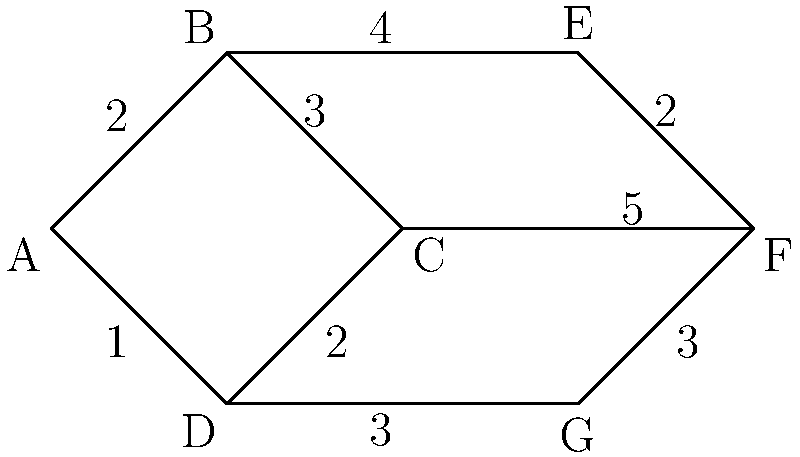As an airline executive, you're tasked with optimizing the security checkpoint layout at a major airport. The graph represents different security stations (nodes) and the paths between them (edges). The weights on the edges represent the average time (in minutes) it takes passengers to move between stations. What is the minimum total time required for a passenger to pass through all security stations, visiting each station exactly once and returning to the starting point? To solve this problem, we need to find the Hamiltonian cycle with the minimum total weight in the given graph. This is known as the Traveling Salesman Problem (TSP). Here's how we can approach it:

1. Identify all possible Hamiltonian cycles in the graph:
   - A-B-C-D-A
   - A-B-E-F-C-D-A
   - A-B-E-F-G-D-A
   - A-D-G-F-E-B-A
   - A-D-G-F-C-B-A

2. Calculate the total weight for each cycle:
   - A-B-C-D-A: 2 + 3 + 2 + 1 = 8 minutes
   - A-B-E-F-C-D-A: 2 + 4 + 2 + 5 + 2 + 1 = 16 minutes
   - A-B-E-F-G-D-A: 2 + 4 + 2 + 3 + 3 + 1 = 15 minutes
   - A-D-G-F-E-B-A: 1 + 3 + 3 + 2 + 4 + 2 = 15 minutes
   - A-D-G-F-C-B-A: 1 + 3 + 3 + 5 + 3 + 2 = 17 minutes

3. Identify the cycle with the minimum total weight:
   The cycle A-B-C-D-A has the minimum total weight of 8 minutes.

Therefore, the minimum total time required for a passenger to pass through all security stations, visiting each station exactly once and returning to the starting point, is 8 minutes.
Answer: 8 minutes 